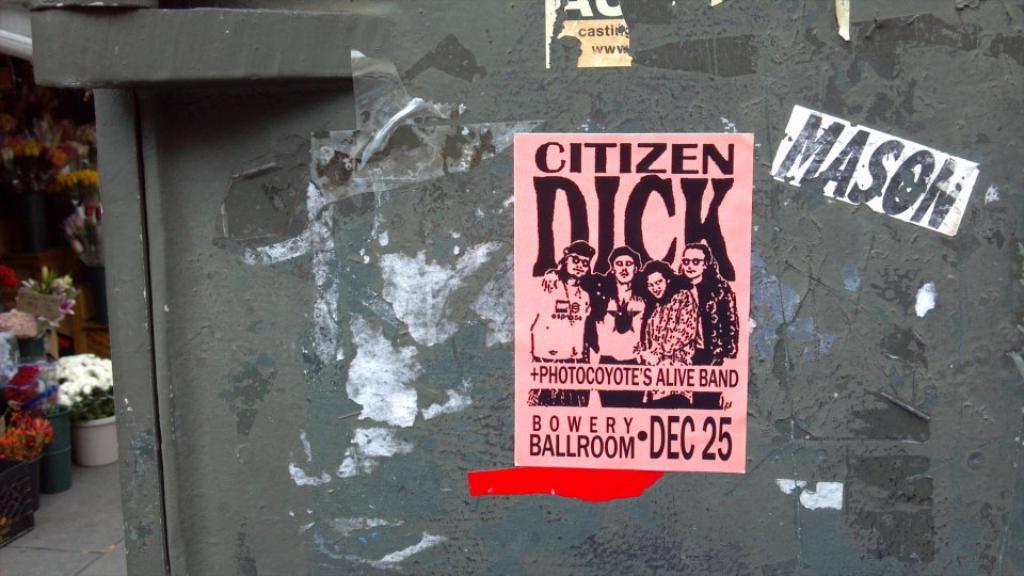What is the date on the poster?
Provide a succinct answer. Dec 25. What is the bands name printed on the pink paper?
Keep it short and to the point. Citizen dick. 